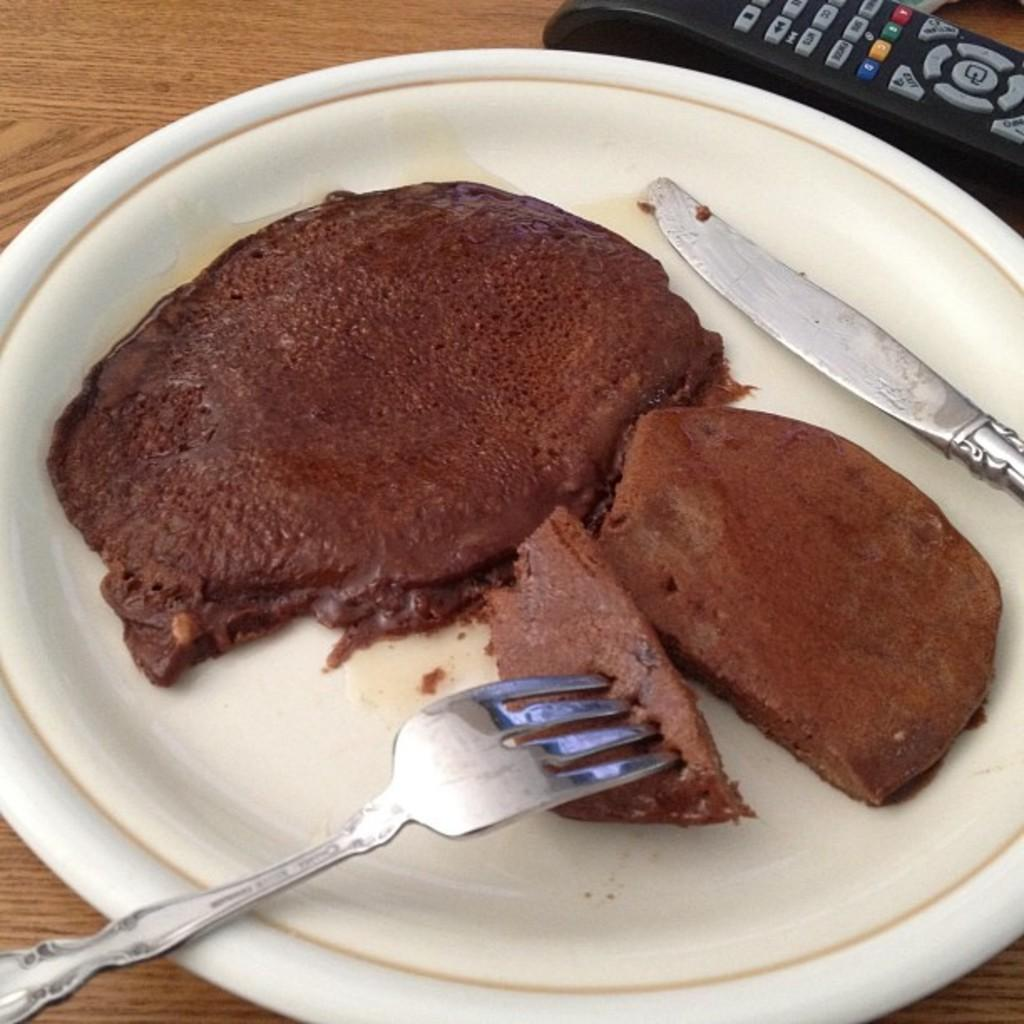What is on the plate in the image? There is food in the plate. What utensils are on the plate? There is a knife and a fork on the plate. What object is not related to eating in the image? There is a remote in the image. What piece of furniture is present in the image? There is a table in the image. What type of neck accessory is being worn by the food in the image? There is no neck accessory present in the image, as the subject is food on a plate. 